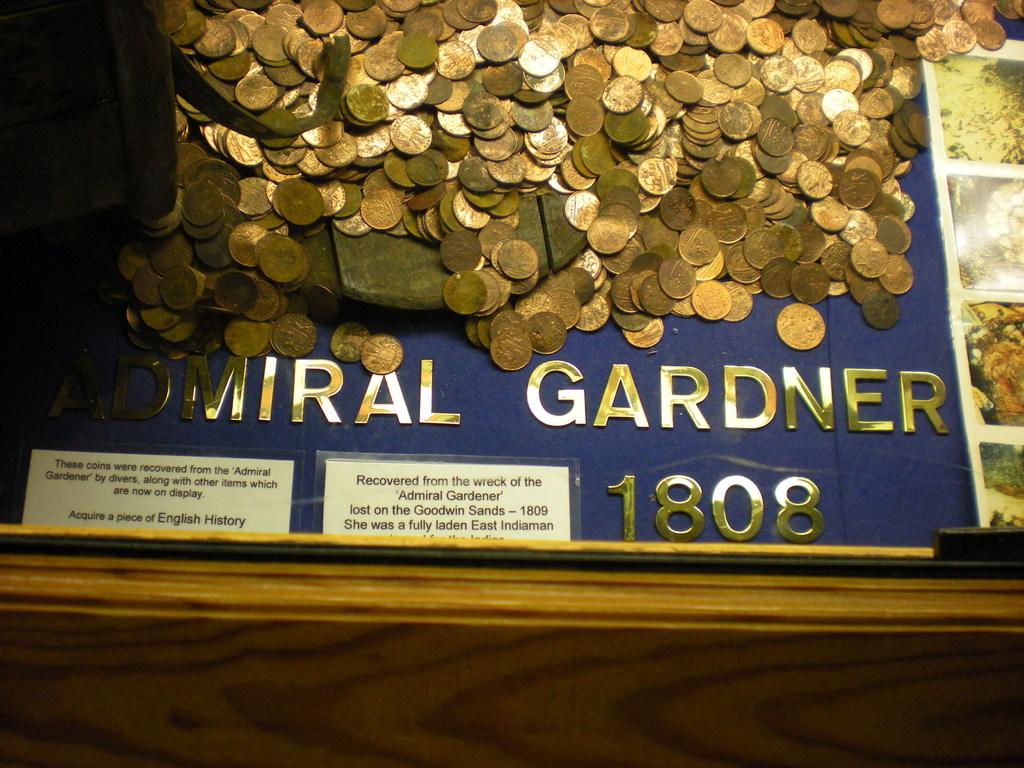What year is featured on this display?
Provide a succinct answer. 1808. What name does it say under the coins?
Your answer should be compact. Admiral gardner. 